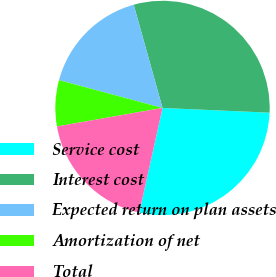Convert chart to OTSL. <chart><loc_0><loc_0><loc_500><loc_500><pie_chart><fcel>Service cost<fcel>Interest cost<fcel>Expected return on plan assets<fcel>Amortization of net<fcel>Total<nl><fcel>27.78%<fcel>30.03%<fcel>16.49%<fcel>6.94%<fcel>18.75%<nl></chart> 